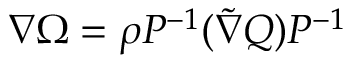<formula> <loc_0><loc_0><loc_500><loc_500>\nabla \Omega = \rho P ^ { - 1 } ( \tilde { \nabla } Q ) P ^ { - 1 }</formula> 